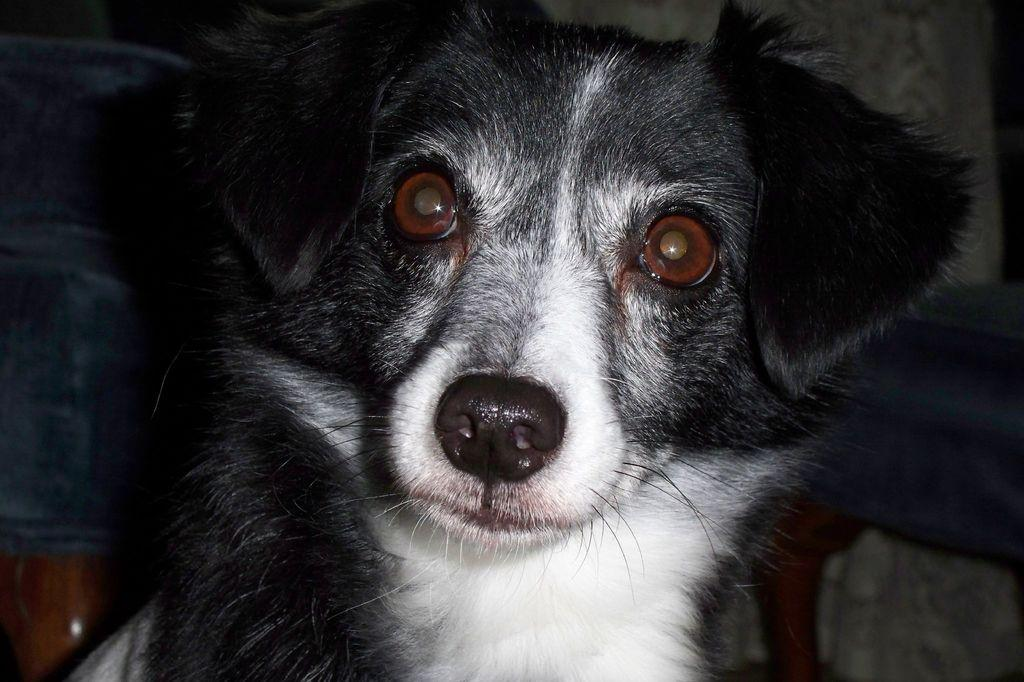What type of animal is present in the image? There is a dog in the image. How many kittens are sitting on the dog's head in the image? There are no kittens present in the image, and therefore no such activity can be observed. 